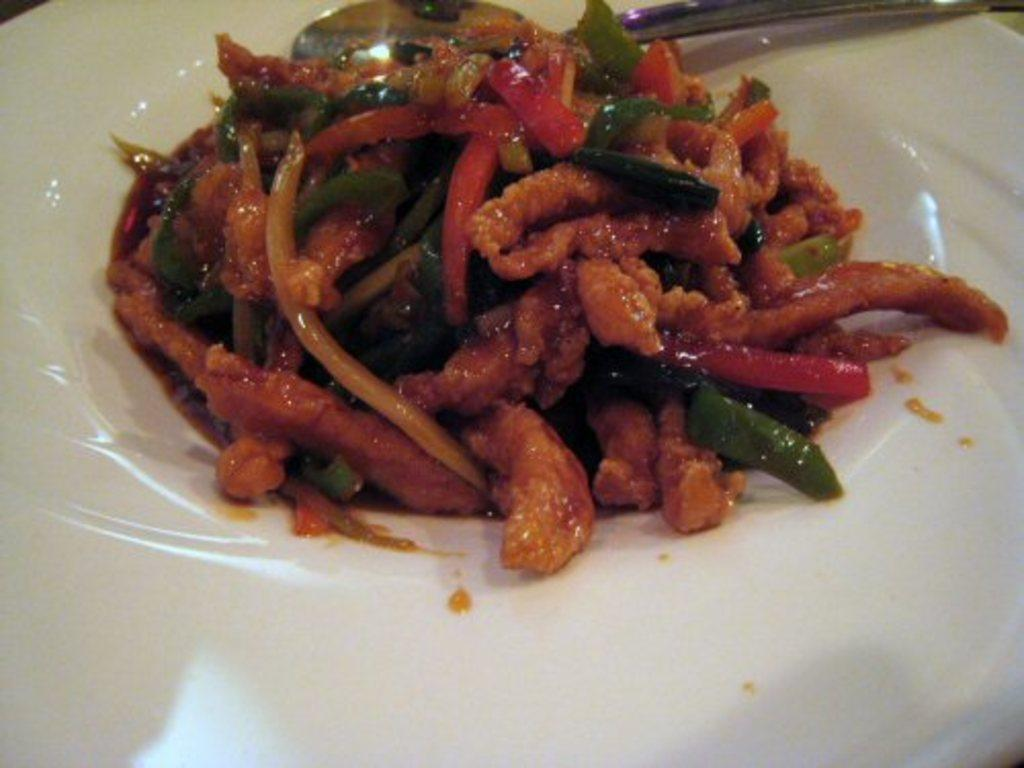What is present on the plate in the image? There is food on the plate in the image. What utensil is visible in the image? There is a spoon in the image. Can you describe the food on the plate? Unfortunately, the specific type of food cannot be determined from the provided facts. What type of animal can be seen playing with an icicle in the image? There is no animal or icicle present in the image; it only features a plate with food and a spoon. 